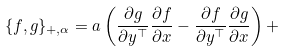Convert formula to latex. <formula><loc_0><loc_0><loc_500><loc_500>\{ f , g \} _ { + , \alpha } = a \left ( \frac { \partial g } { \partial y ^ { \top } } \frac { \partial f } { \partial x } - \frac { \partial f } { \partial y ^ { \top } } \frac { \partial g } { \partial x } \right ) +</formula> 